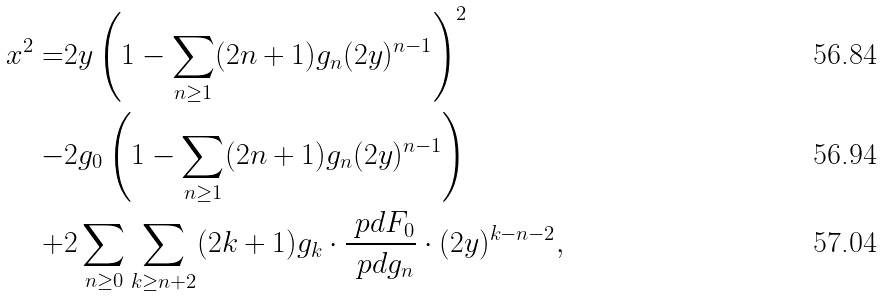Convert formula to latex. <formula><loc_0><loc_0><loc_500><loc_500>x ^ { 2 } = & 2 y \left ( 1 - \sum _ { n \geq 1 } ( 2 n + 1 ) g _ { n } ( 2 y ) ^ { n - 1 } \right ) ^ { 2 } \\ - & 2 g _ { 0 } \left ( 1 - \sum _ { n \geq 1 } ( 2 n + 1 ) g _ { n } ( 2 y ) ^ { n - 1 } \right ) \\ + & 2 \sum _ { n \geq 0 } \sum _ { k \geq n + 2 } ( 2 k + 1 ) g _ { k } \cdot \frac { \ p d F _ { 0 } } { \ p d g _ { n } } \cdot ( 2 y ) ^ { k - n - 2 } ,</formula> 